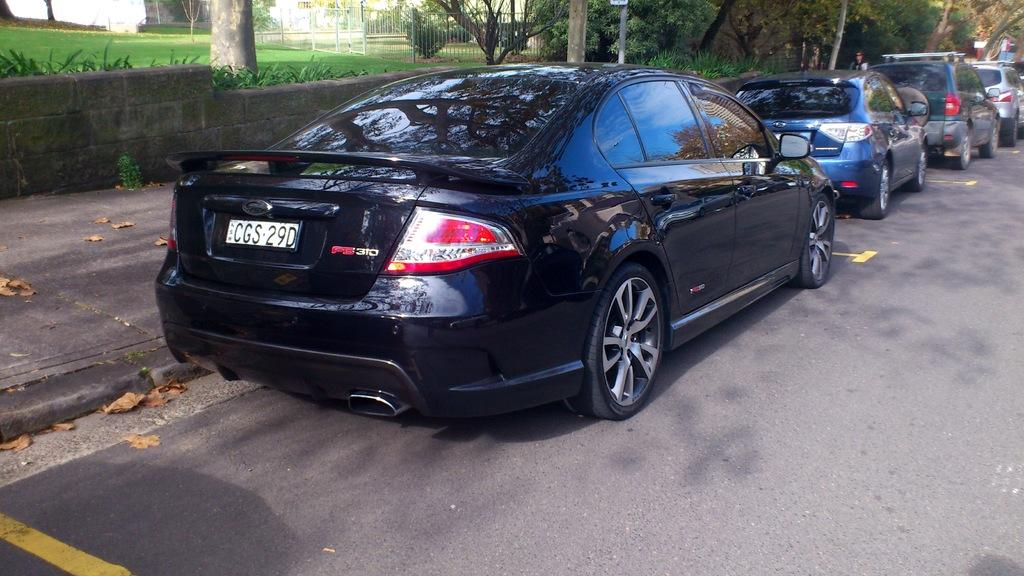What types of objects are present in the image? There are vehicles in the image. Can you describe one of the vehicles in more detail? One of the vehicles is black. What can be seen in the background of the image? There are trees visible in the background of the image. What color are the trees? The trees are green. What type of structure is present in the image? There is railing in the image. Can you tell me how many times the person in the image sneezes? There is no person present in the image, and therefore no sneezing can be observed. What type of rifle is visible in the image? There is no rifle present in the image. 